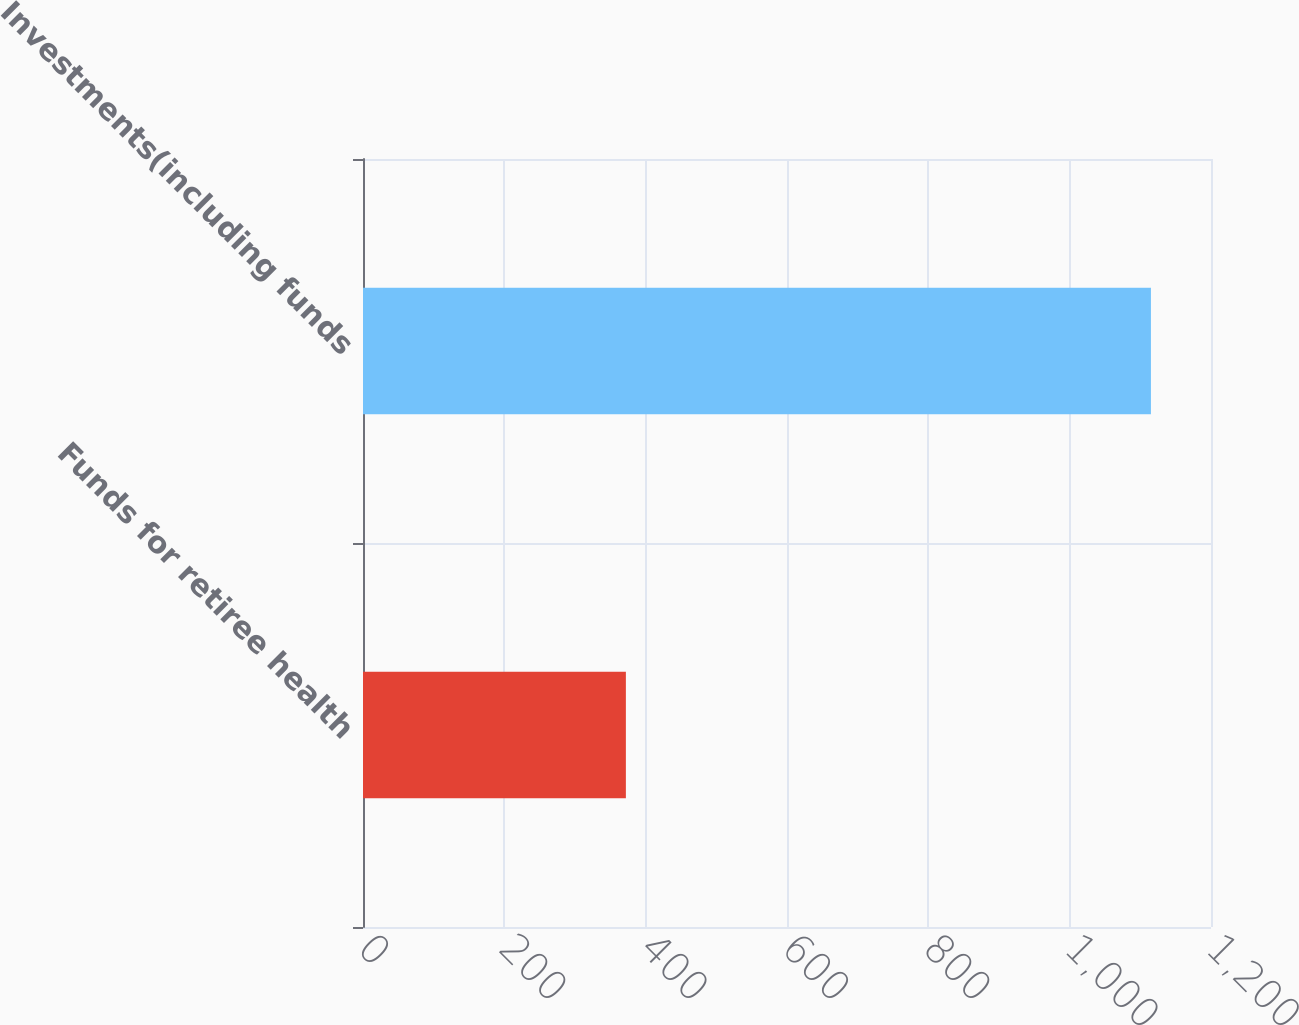<chart> <loc_0><loc_0><loc_500><loc_500><bar_chart><fcel>Funds for retiree health<fcel>Investments(including funds<nl><fcel>372<fcel>1115<nl></chart> 